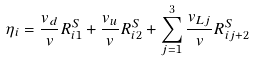<formula> <loc_0><loc_0><loc_500><loc_500>\eta _ { i } = \frac { v _ { d } } { v } R ^ { S } _ { i 1 } + \frac { v _ { u } } { v } R ^ { S } _ { i 2 } + \sum _ { j = 1 } ^ { 3 } \frac { v _ { L j } } { v } R ^ { S } _ { i j + 2 }</formula> 